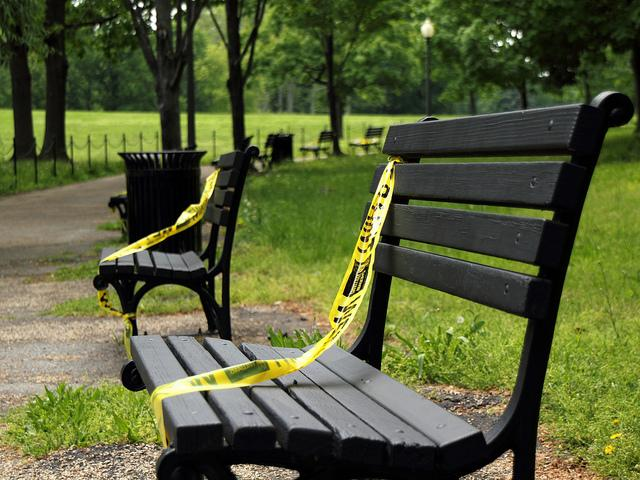For what reason were the benches likely sealed off with caution tape? wet paint 